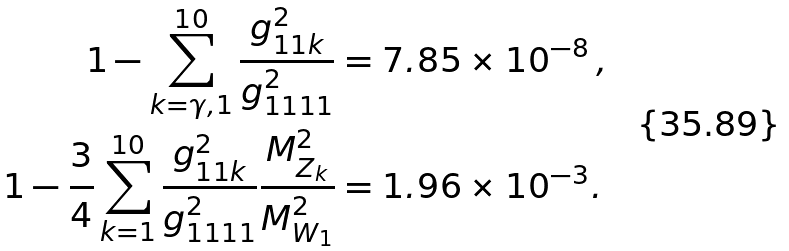Convert formula to latex. <formula><loc_0><loc_0><loc_500><loc_500>1 - \sum _ { k = \gamma , 1 } ^ { 1 0 } \frac { g ^ { 2 } _ { 1 1 k } } { g ^ { 2 } _ { 1 1 1 1 } } & = 7 . 8 5 \times 1 0 ^ { - 8 } \, , \\ 1 - \frac { 3 } { 4 } \sum _ { k = 1 } ^ { 1 0 } \frac { g ^ { 2 } _ { 1 1 k } } { g ^ { 2 } _ { 1 1 1 1 } } \frac { M ^ { 2 } _ { Z _ { k } } } { M _ { W _ { 1 } } ^ { 2 } } & = 1 . 9 6 \times 1 0 ^ { - 3 } .</formula> 